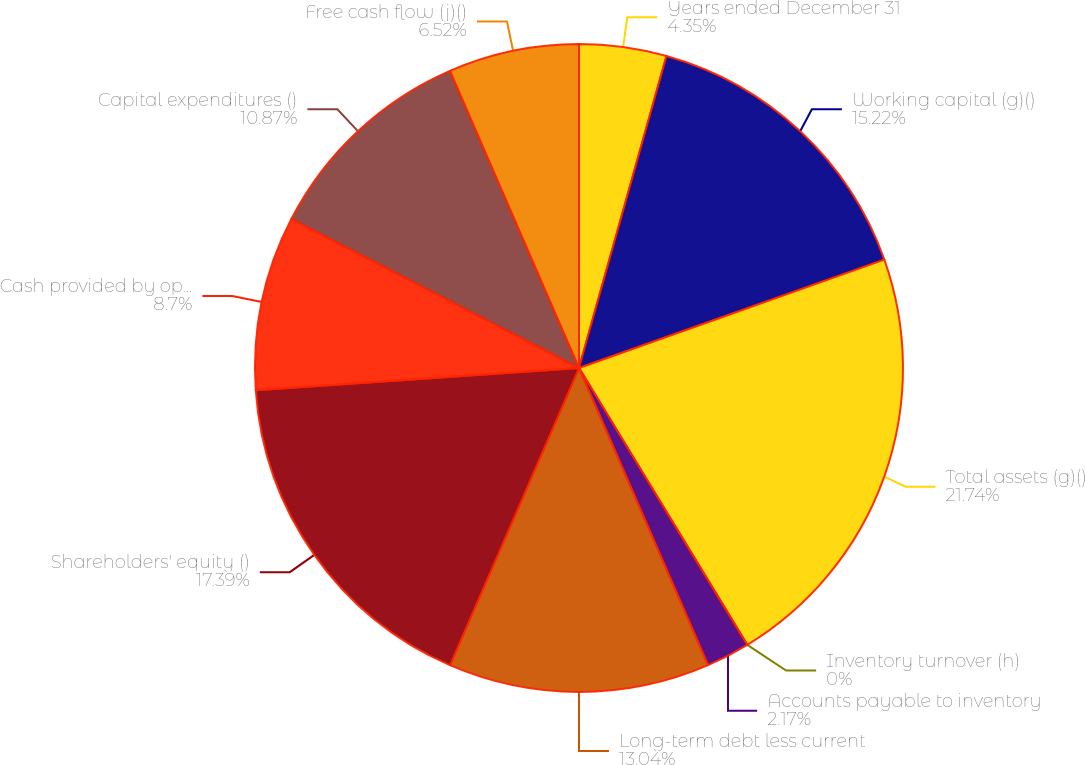Convert chart to OTSL. <chart><loc_0><loc_0><loc_500><loc_500><pie_chart><fcel>Years ended December 31<fcel>Working capital (g)()<fcel>Total assets (g)()<fcel>Inventory turnover (h)<fcel>Accounts payable to inventory<fcel>Long-term debt less current<fcel>Shareholders' equity ()<fcel>Cash provided by operating<fcel>Capital expenditures ()<fcel>Free cash flow (j)()<nl><fcel>4.35%<fcel>15.22%<fcel>21.74%<fcel>0.0%<fcel>2.17%<fcel>13.04%<fcel>17.39%<fcel>8.7%<fcel>10.87%<fcel>6.52%<nl></chart> 